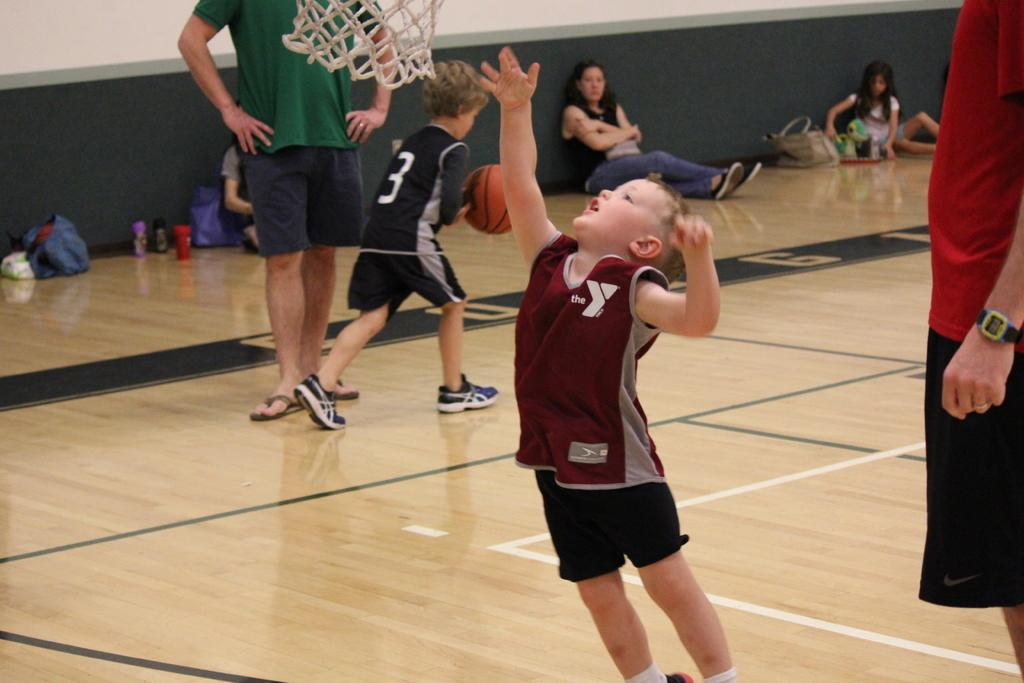What are the persons in the image doing? The persons in the image are sitting and standing on the floor. What can be seen in the background of the image? In the background of the image, there are water bottles, bags, and walls. What type of insurance is being discussed by the persons in the image? There is no indication in the image that the persons are discussing insurance. What type of rice is being served to the persons in the image? There is no rice present in the image. 